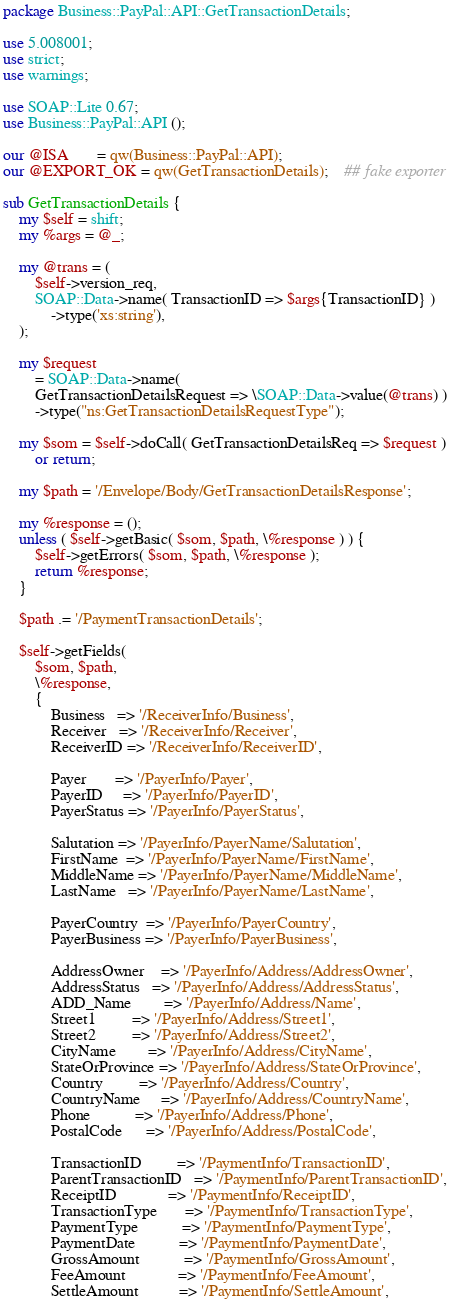<code> <loc_0><loc_0><loc_500><loc_500><_Perl_>package Business::PayPal::API::GetTransactionDetails;

use 5.008001;
use strict;
use warnings;

use SOAP::Lite 0.67;
use Business::PayPal::API ();

our @ISA       = qw(Business::PayPal::API);
our @EXPORT_OK = qw(GetTransactionDetails);    ## fake exporter

sub GetTransactionDetails {
    my $self = shift;
    my %args = @_;

    my @trans = (
        $self->version_req,
        SOAP::Data->name( TransactionID => $args{TransactionID} )
            ->type('xs:string'),
    );

    my $request
        = SOAP::Data->name(
        GetTransactionDetailsRequest => \SOAP::Data->value(@trans) )
        ->type("ns:GetTransactionDetailsRequestType");

    my $som = $self->doCall( GetTransactionDetailsReq => $request )
        or return;

    my $path = '/Envelope/Body/GetTransactionDetailsResponse';

    my %response = ();
    unless ( $self->getBasic( $som, $path, \%response ) ) {
        $self->getErrors( $som, $path, \%response );
        return %response;
    }

    $path .= '/PaymentTransactionDetails';

    $self->getFields(
        $som, $path,
        \%response,
        {
            Business   => '/ReceiverInfo/Business',
            Receiver   => '/ReceiverInfo/Receiver',
            ReceiverID => '/ReceiverInfo/ReceiverID',

            Payer       => '/PayerInfo/Payer',
            PayerID     => '/PayerInfo/PayerID',
            PayerStatus => '/PayerInfo/PayerStatus',

            Salutation => '/PayerInfo/PayerName/Salutation',
            FirstName  => '/PayerInfo/PayerName/FirstName',
            MiddleName => '/PayerInfo/PayerName/MiddleName',
            LastName   => '/PayerInfo/PayerName/LastName',

            PayerCountry  => '/PayerInfo/PayerCountry',
            PayerBusiness => '/PayerInfo/PayerBusiness',

            AddressOwner    => '/PayerInfo/Address/AddressOwner',
            AddressStatus   => '/PayerInfo/Address/AddressStatus',
            ADD_Name        => '/PayerInfo/Address/Name',
            Street1         => '/PayerInfo/Address/Street1',
            Street2         => '/PayerInfo/Address/Street2',
            CityName        => '/PayerInfo/Address/CityName',
            StateOrProvince => '/PayerInfo/Address/StateOrProvince',
            Country         => '/PayerInfo/Address/Country',
            CountryName     => '/PayerInfo/Address/CountryName',
            Phone           => '/PayerInfo/Address/Phone',
            PostalCode      => '/PayerInfo/Address/PostalCode',

            TransactionID         => '/PaymentInfo/TransactionID',
            ParentTransactionID   => '/PaymentInfo/ParentTransactionID',
            ReceiptID             => '/PaymentInfo/ReceiptID',
            TransactionType       => '/PaymentInfo/TransactionType',
            PaymentType           => '/PaymentInfo/PaymentType',
            PaymentDate           => '/PaymentInfo/PaymentDate',
            GrossAmount           => '/PaymentInfo/GrossAmount',
            FeeAmount             => '/PaymentInfo/FeeAmount',
            SettleAmount          => '/PaymentInfo/SettleAmount',</code> 